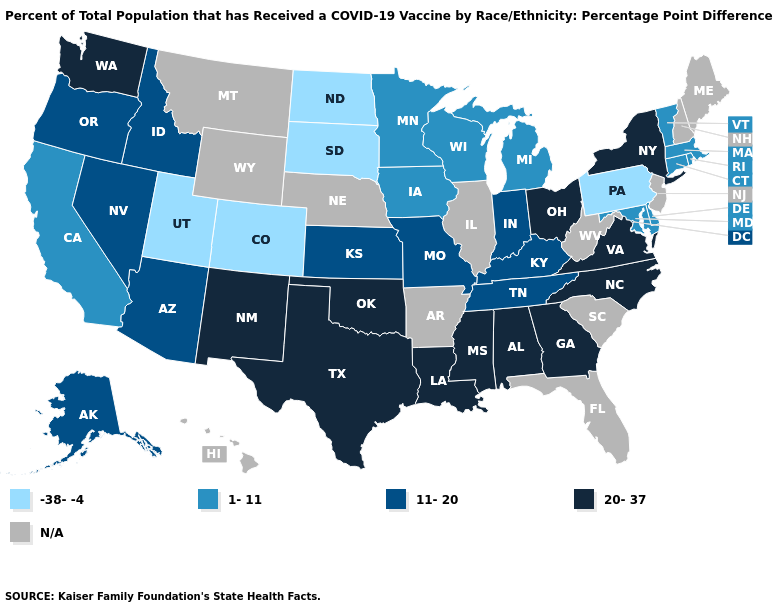What is the value of Ohio?
Concise answer only. 20-37. Does the first symbol in the legend represent the smallest category?
Concise answer only. Yes. Does Indiana have the lowest value in the USA?
Short answer required. No. What is the value of Missouri?
Give a very brief answer. 11-20. Does the first symbol in the legend represent the smallest category?
Quick response, please. Yes. Name the states that have a value in the range -38--4?
Quick response, please. Colorado, North Dakota, Pennsylvania, South Dakota, Utah. Which states hav the highest value in the Northeast?
Answer briefly. New York. Name the states that have a value in the range N/A?
Write a very short answer. Arkansas, Florida, Hawaii, Illinois, Maine, Montana, Nebraska, New Hampshire, New Jersey, South Carolina, West Virginia, Wyoming. Does North Carolina have the highest value in the South?
Keep it brief. Yes. Name the states that have a value in the range -38--4?
Write a very short answer. Colorado, North Dakota, Pennsylvania, South Dakota, Utah. Among the states that border Georgia , which have the highest value?
Answer briefly. Alabama, North Carolina. What is the lowest value in the USA?
Quick response, please. -38--4. 